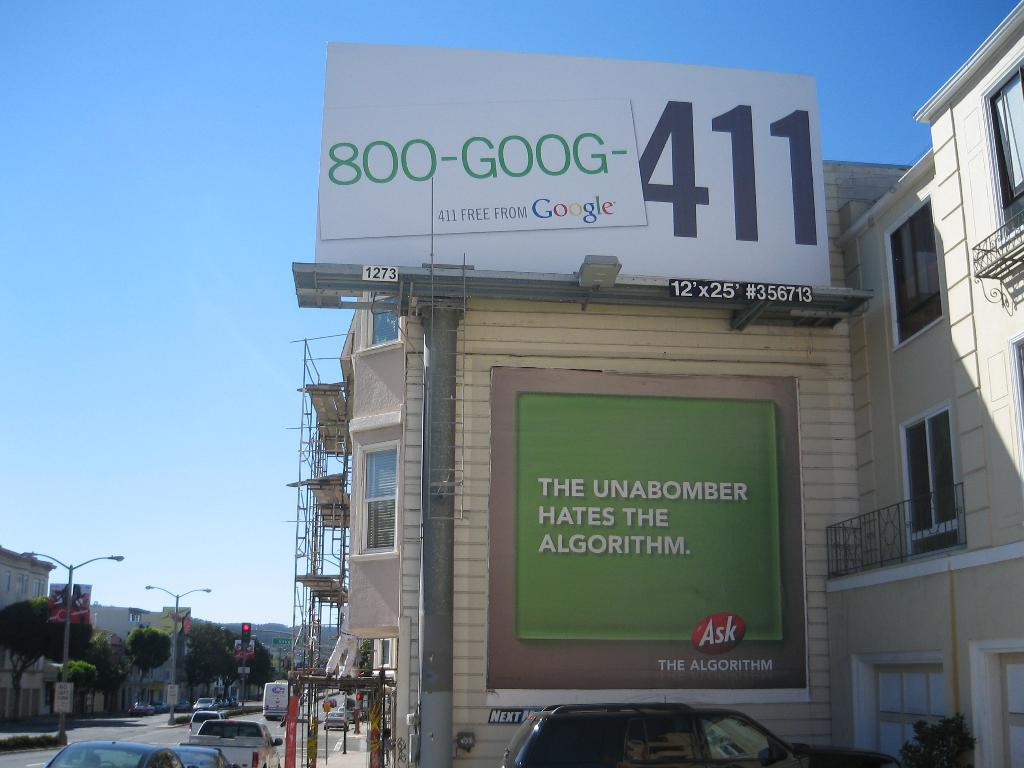Provide a one-sentence caption for the provided image. A busy city street with a giant billboard that says 411. 